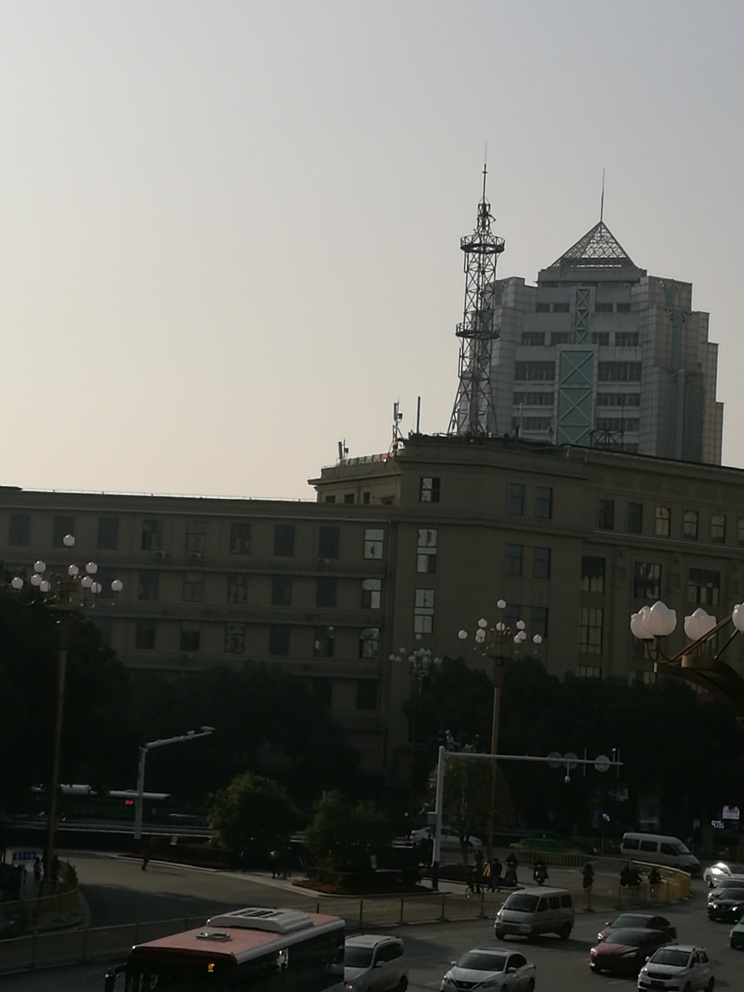What type of environment does this image depict? The image depicts an urban environment, likely a cityscape where commercial and potentially residential buildings coexist. The presence of vehicles on the road, including a bus, suggest that this area experiences regular traffic, indicative of a functioning urban center. Streetlights and the mix of architecture imply a blend of utility and design, common in city spaces. Overall, the environment seems to be a busy and populated area with a variety of functional structures. 